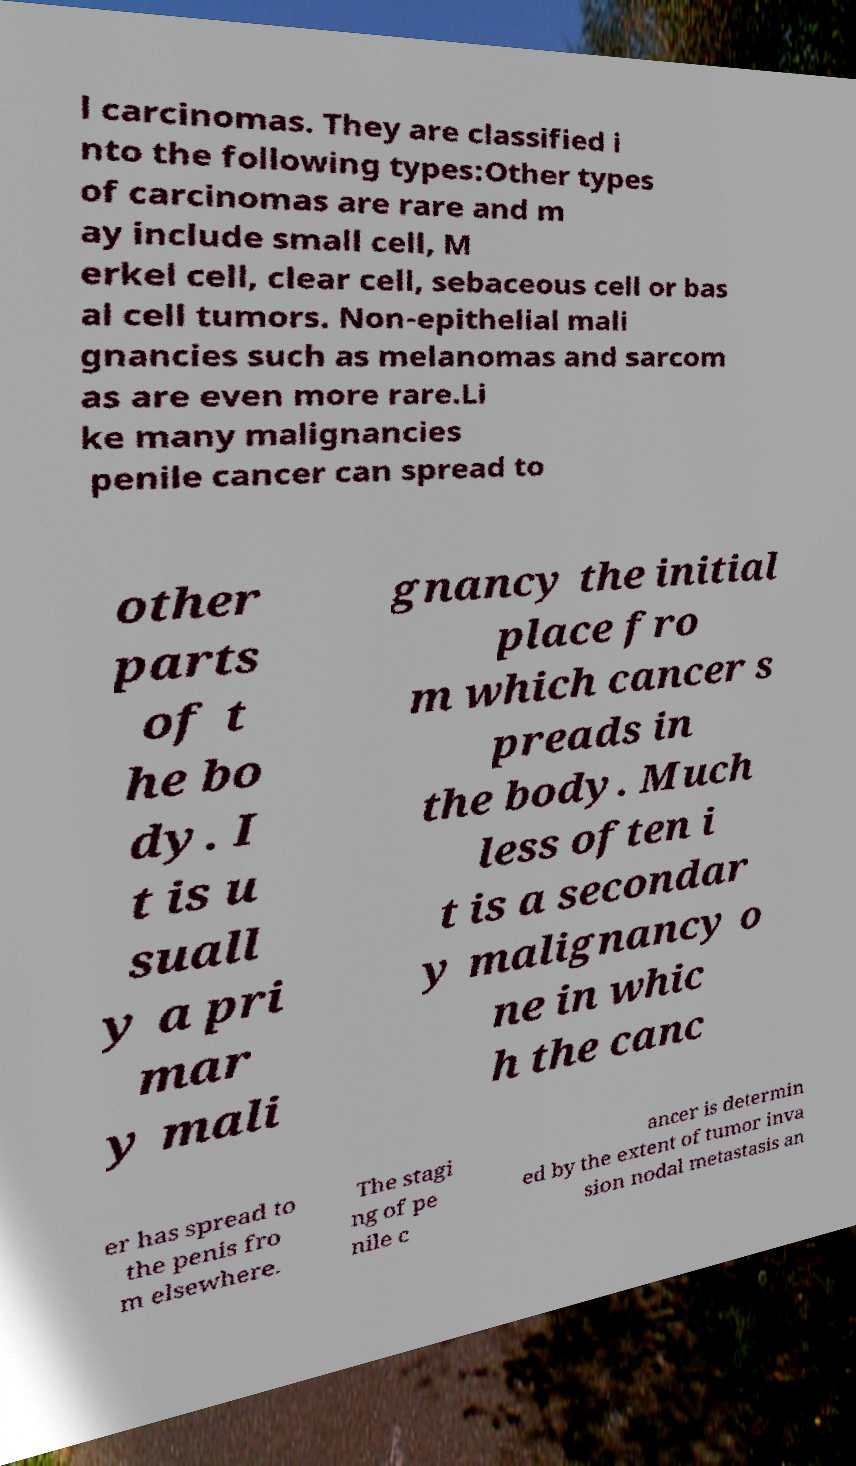For documentation purposes, I need the text within this image transcribed. Could you provide that? l carcinomas. They are classified i nto the following types:Other types of carcinomas are rare and m ay include small cell, M erkel cell, clear cell, sebaceous cell or bas al cell tumors. Non-epithelial mali gnancies such as melanomas and sarcom as are even more rare.Li ke many malignancies penile cancer can spread to other parts of t he bo dy. I t is u suall y a pri mar y mali gnancy the initial place fro m which cancer s preads in the body. Much less often i t is a secondar y malignancy o ne in whic h the canc er has spread to the penis fro m elsewhere. The stagi ng of pe nile c ancer is determin ed by the extent of tumor inva sion nodal metastasis an 